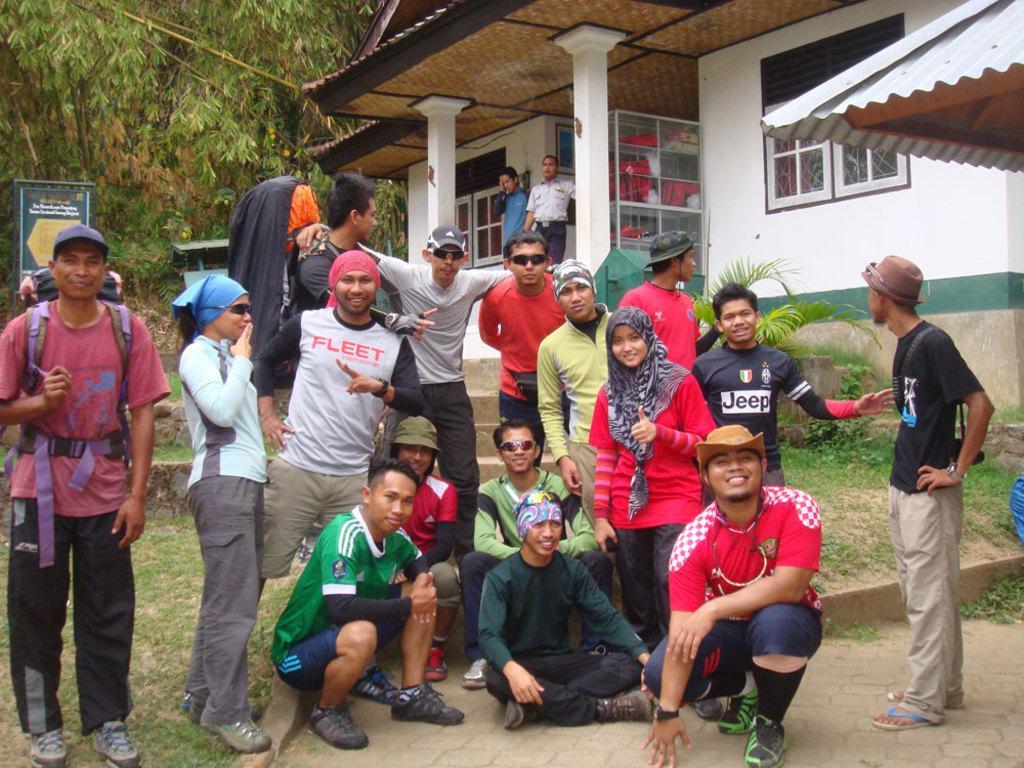How would you summarize this image in a sentence or two? There are a group of people standing and few people sitting. This looks like a house with the windows and doors. I can see a board. These are the trees with branches and leaves. On the right side of the image, I think this is a roof. I can see a plant and the grass. 